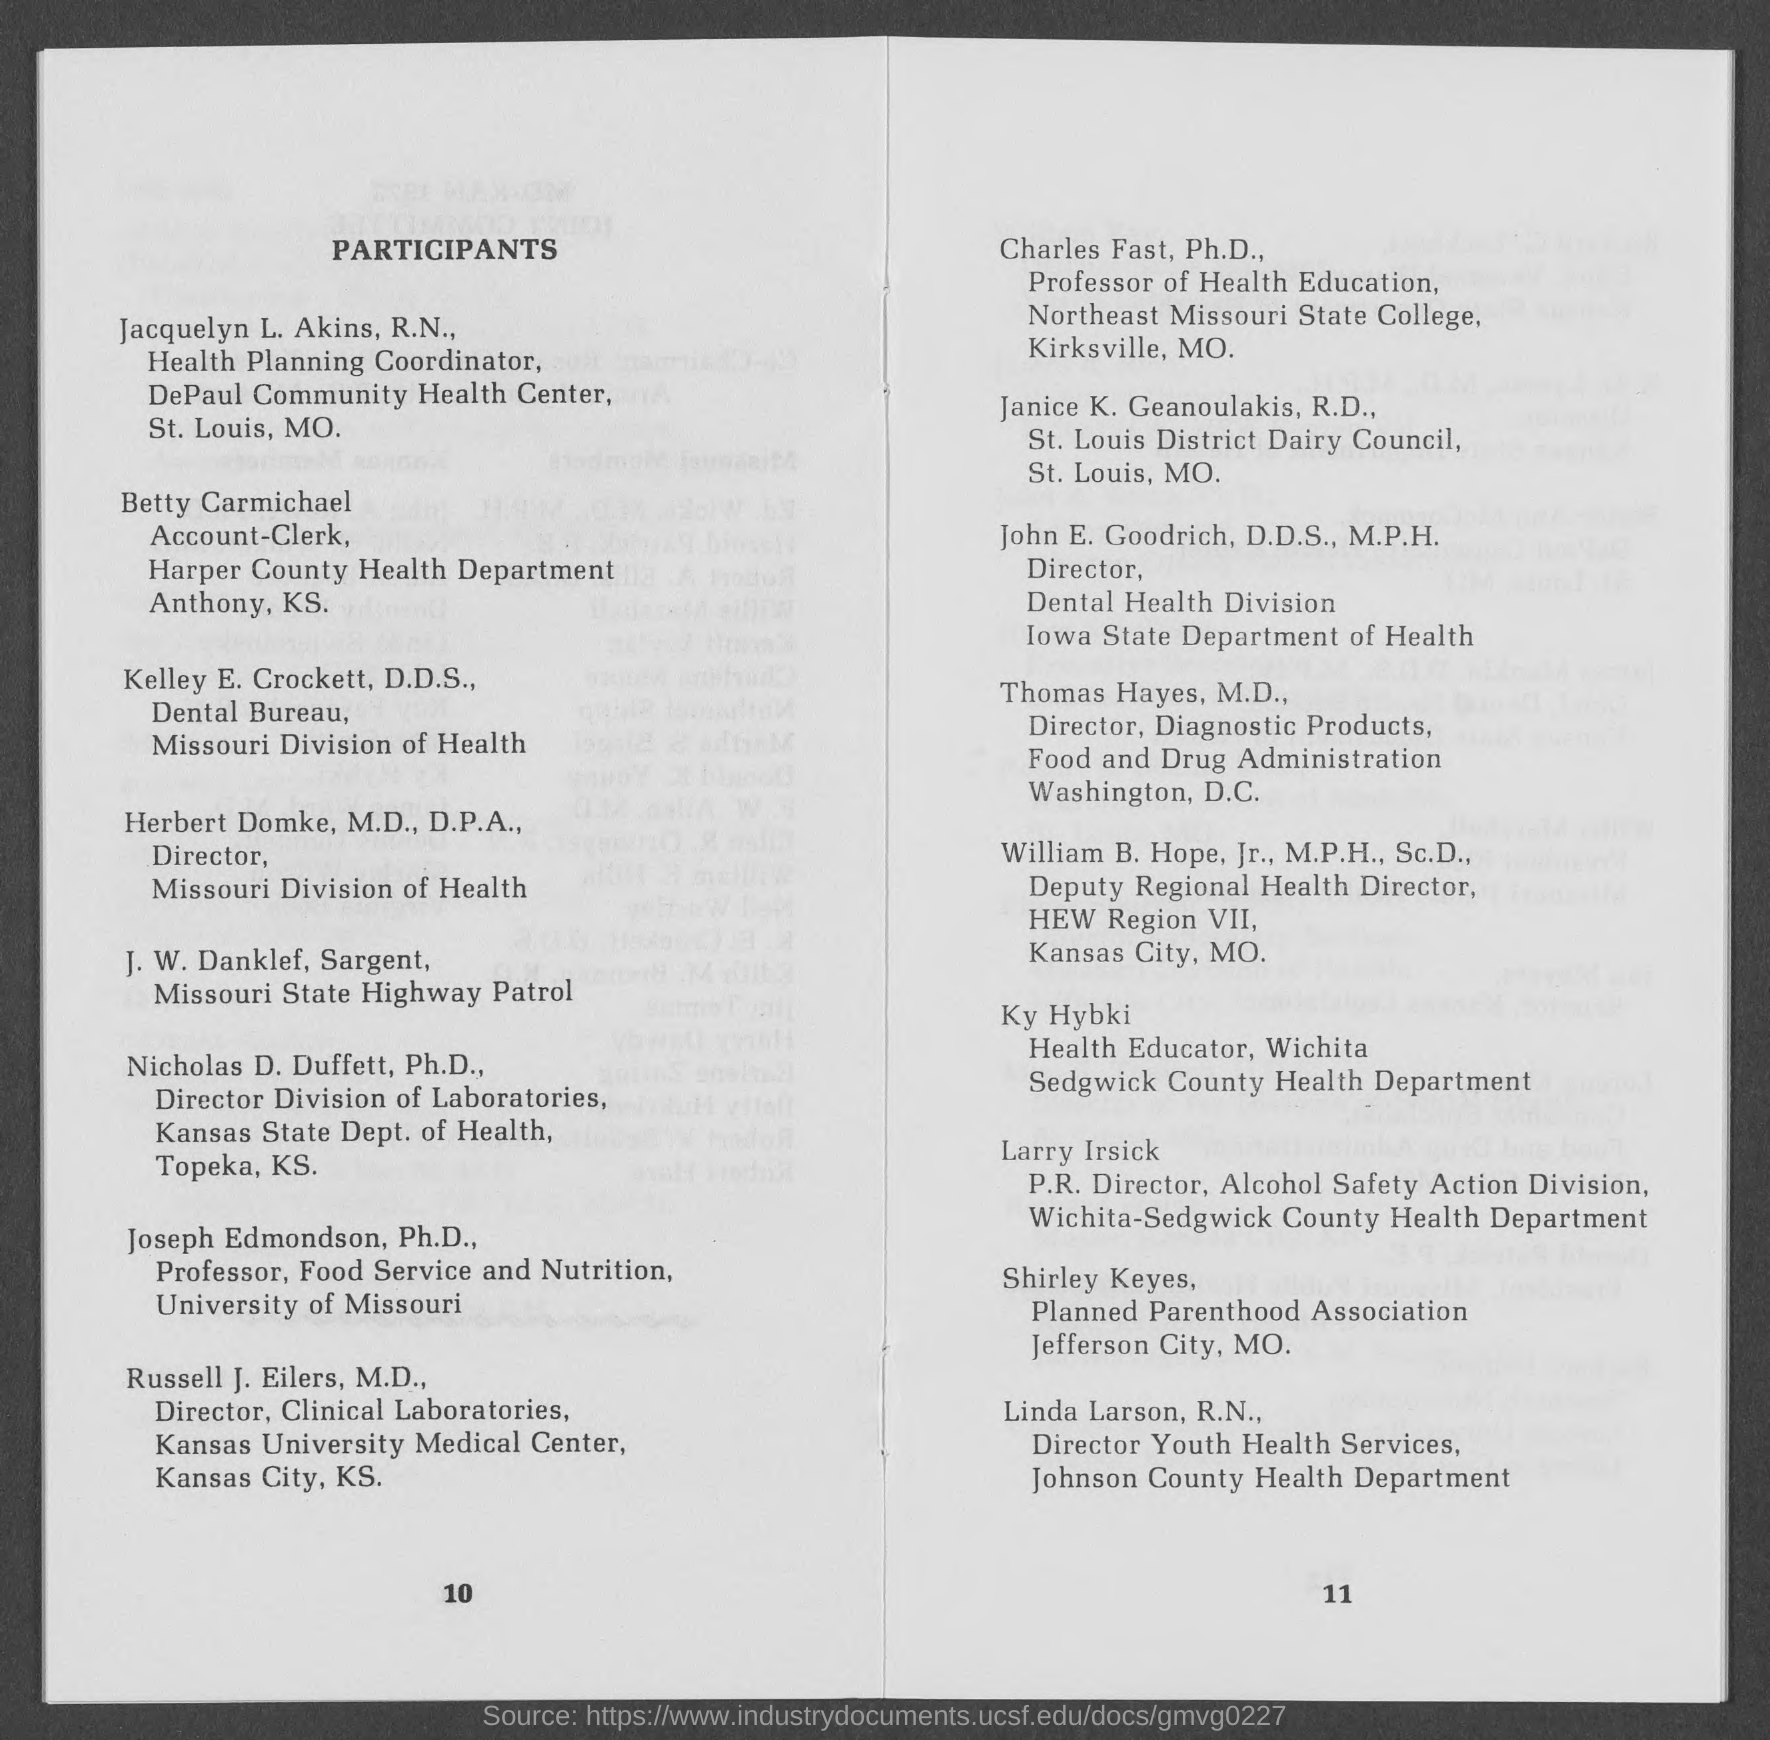Specify some key components in this picture. John E. Goodrich, D.D.S., M.P.H., is the director of the Dental Health Division at the Iowa State Department of Health. The individual who serves as the representative of the Director of Youth Health Services at the Johnson County Health Department is named Linda Larson, who holds the credential of Registered Nurse. The heading of the document at the top-left is 'Participants.' Nicholas D. Duffett, Ph.D., is the Director of the Division of Laboratories at the Kansas State Department of Health. The Account-clerk at Anthony. K.S is named Betty Carmichael. 